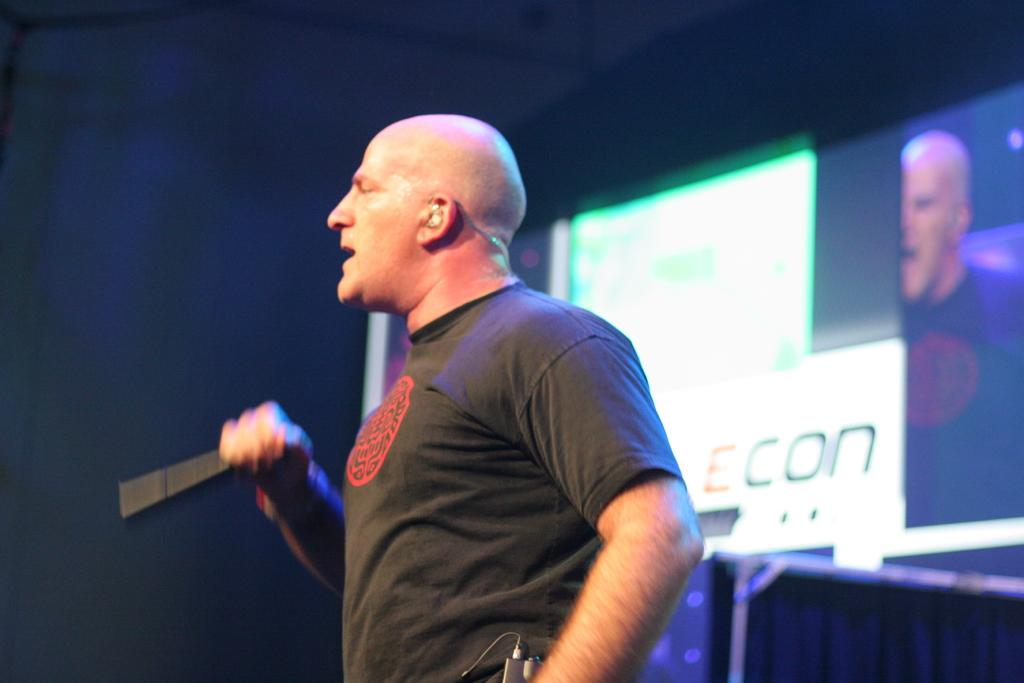What is the main subject of the image? The main subject of the image is a man. What is the man doing in the image? The man is standing and talking into a microphone. What is the man wearing in the image? The man is wearing a black t-shirt. What can be seen on the right side of the image? There is an electronic display on the right side of the image. Can you tell me how many pages are in the book the man is holding in the image? There is no book present in the image, so it is not possible to determine the number of pages. 